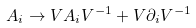Convert formula to latex. <formula><loc_0><loc_0><loc_500><loc_500>A _ { i } \rightarrow V A _ { i } V ^ { - 1 } + V \partial _ { i } V ^ { - 1 }</formula> 